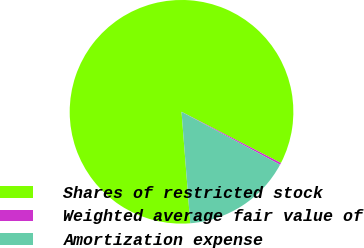Convert chart. <chart><loc_0><loc_0><loc_500><loc_500><pie_chart><fcel>Shares of restricted stock<fcel>Weighted average fair value of<fcel>Amortization expense<nl><fcel>83.81%<fcel>0.28%<fcel>15.91%<nl></chart> 